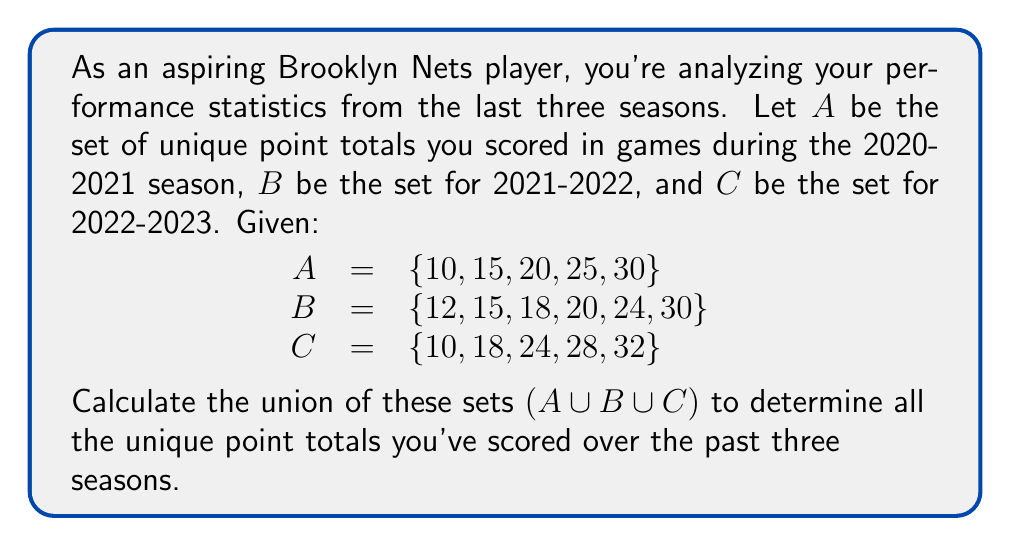Give your solution to this math problem. To find the union of sets A, B, and C, we need to combine all unique elements from all three sets. Let's approach this step-by-step:

1) First, let's write out all the elements from set A:
   A = {10, 15, 20, 25, 30}

2) Now, let's add the unique elements from set B that are not already in A:
   • 12, 18, and 24 are not in A, so we add them
   • 15, 20, and 30 are already in A, so we don't need to add them again
   A ∪ B = {10, 12, 15, 18, 20, 24, 25, 30}

3) Finally, let's add the unique elements from set C that are not already in A ∪ B:
   • 28 and 32 are not in A ∪ B, so we add them
   • 10, 18, and 24 are already in A ∪ B, so we don't add them again

4) Therefore, the final union A ∪ B ∪ C is:
   A ∪ B ∪ C = {10, 12, 15, 18, 20, 24, 25, 28, 30, 32}

We can represent this mathematically as:

$$A \cup B \cup C = \{x | x \in A \text{ or } x \in B \text{ or } x \in C\}$$

This set contains all the unique point totals you've scored over the past three seasons.
Answer: {10, 12, 15, 18, 20, 24, 25, 28, 30, 32} 